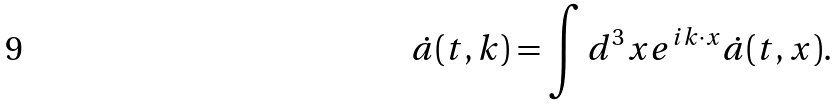<formula> <loc_0><loc_0><loc_500><loc_500>\dot { a } ( t , { k } ) = \int d ^ { 3 } { x } e ^ { i { k \cdot x } } \dot { a } ( t , { x } ) .</formula> 